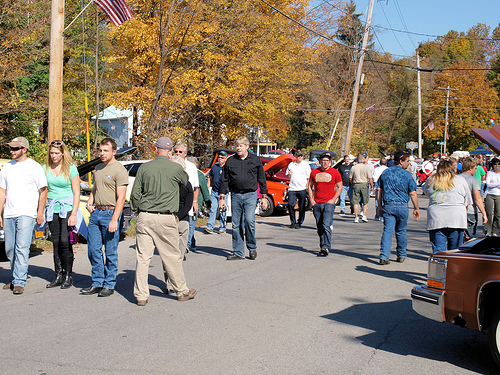<image>
Is the white man to the right of the brown man? Yes. From this viewpoint, the white man is positioned to the right side relative to the brown man. 